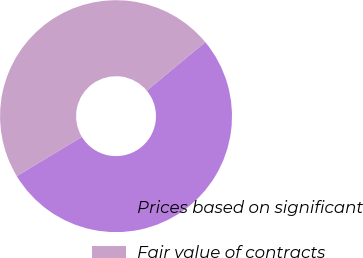<chart> <loc_0><loc_0><loc_500><loc_500><pie_chart><fcel>Prices based on significant<fcel>Fair value of contracts<nl><fcel>52.38%<fcel>47.62%<nl></chart> 